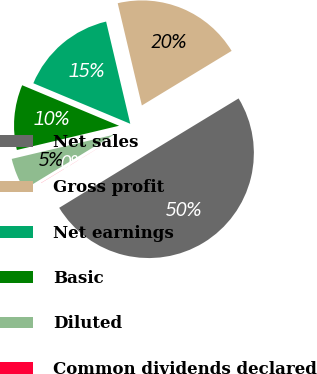Convert chart. <chart><loc_0><loc_0><loc_500><loc_500><pie_chart><fcel>Net sales<fcel>Gross profit<fcel>Net earnings<fcel>Basic<fcel>Diluted<fcel>Common dividends declared<nl><fcel>49.96%<fcel>20.0%<fcel>15.0%<fcel>10.01%<fcel>5.01%<fcel>0.02%<nl></chart> 